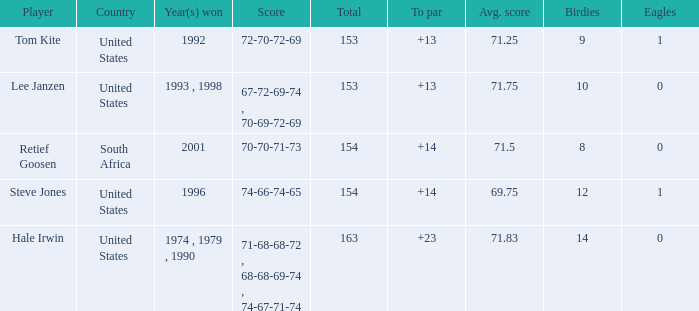In what year did the United States win To par greater than 14 1974 , 1979 , 1990. 